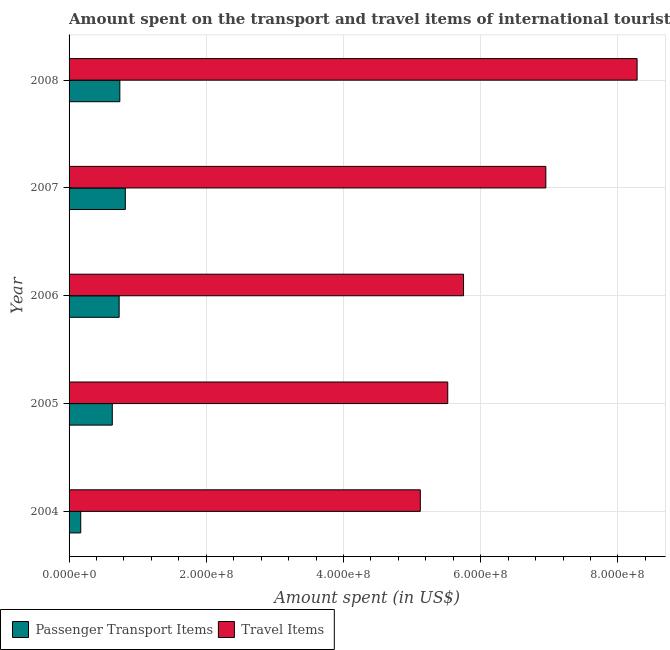How many different coloured bars are there?
Provide a succinct answer. 2. How many groups of bars are there?
Offer a very short reply. 5. Are the number of bars per tick equal to the number of legend labels?
Provide a short and direct response. Yes. How many bars are there on the 2nd tick from the top?
Provide a succinct answer. 2. What is the label of the 1st group of bars from the top?
Offer a terse response. 2008. In how many cases, is the number of bars for a given year not equal to the number of legend labels?
Offer a very short reply. 0. What is the amount spent on passenger transport items in 2008?
Your answer should be very brief. 7.40e+07. Across all years, what is the maximum amount spent on passenger transport items?
Keep it short and to the point. 8.20e+07. Across all years, what is the minimum amount spent in travel items?
Your answer should be very brief. 5.12e+08. What is the total amount spent in travel items in the graph?
Offer a terse response. 3.16e+09. What is the difference between the amount spent on passenger transport items in 2005 and that in 2006?
Your answer should be compact. -1.00e+07. What is the difference between the amount spent on passenger transport items in 2004 and the amount spent in travel items in 2005?
Offer a very short reply. -5.35e+08. What is the average amount spent in travel items per year?
Your response must be concise. 6.32e+08. In the year 2005, what is the difference between the amount spent in travel items and amount spent on passenger transport items?
Make the answer very short. 4.89e+08. What is the ratio of the amount spent in travel items in 2004 to that in 2005?
Provide a short and direct response. 0.93. Is the amount spent on passenger transport items in 2004 less than that in 2005?
Offer a very short reply. Yes. Is the difference between the amount spent on passenger transport items in 2004 and 2005 greater than the difference between the amount spent in travel items in 2004 and 2005?
Make the answer very short. No. What is the difference between the highest and the lowest amount spent in travel items?
Make the answer very short. 3.16e+08. What does the 1st bar from the top in 2006 represents?
Keep it short and to the point. Travel Items. What does the 2nd bar from the bottom in 2005 represents?
Your answer should be very brief. Travel Items. Are all the bars in the graph horizontal?
Your answer should be very brief. Yes. How many legend labels are there?
Your answer should be very brief. 2. What is the title of the graph?
Make the answer very short. Amount spent on the transport and travel items of international tourists visited in Macao. Does "Exports of goods" appear as one of the legend labels in the graph?
Ensure brevity in your answer.  No. What is the label or title of the X-axis?
Ensure brevity in your answer.  Amount spent (in US$). What is the label or title of the Y-axis?
Your answer should be compact. Year. What is the Amount spent (in US$) in Passenger Transport Items in 2004?
Keep it short and to the point. 1.70e+07. What is the Amount spent (in US$) in Travel Items in 2004?
Your response must be concise. 5.12e+08. What is the Amount spent (in US$) of Passenger Transport Items in 2005?
Provide a short and direct response. 6.30e+07. What is the Amount spent (in US$) of Travel Items in 2005?
Your answer should be compact. 5.52e+08. What is the Amount spent (in US$) of Passenger Transport Items in 2006?
Give a very brief answer. 7.30e+07. What is the Amount spent (in US$) in Travel Items in 2006?
Offer a very short reply. 5.75e+08. What is the Amount spent (in US$) in Passenger Transport Items in 2007?
Provide a succinct answer. 8.20e+07. What is the Amount spent (in US$) of Travel Items in 2007?
Make the answer very short. 6.95e+08. What is the Amount spent (in US$) in Passenger Transport Items in 2008?
Your answer should be very brief. 7.40e+07. What is the Amount spent (in US$) in Travel Items in 2008?
Ensure brevity in your answer.  8.28e+08. Across all years, what is the maximum Amount spent (in US$) in Passenger Transport Items?
Ensure brevity in your answer.  8.20e+07. Across all years, what is the maximum Amount spent (in US$) in Travel Items?
Ensure brevity in your answer.  8.28e+08. Across all years, what is the minimum Amount spent (in US$) of Passenger Transport Items?
Provide a short and direct response. 1.70e+07. Across all years, what is the minimum Amount spent (in US$) in Travel Items?
Give a very brief answer. 5.12e+08. What is the total Amount spent (in US$) of Passenger Transport Items in the graph?
Offer a terse response. 3.09e+08. What is the total Amount spent (in US$) of Travel Items in the graph?
Provide a short and direct response. 3.16e+09. What is the difference between the Amount spent (in US$) in Passenger Transport Items in 2004 and that in 2005?
Offer a terse response. -4.60e+07. What is the difference between the Amount spent (in US$) in Travel Items in 2004 and that in 2005?
Keep it short and to the point. -4.00e+07. What is the difference between the Amount spent (in US$) in Passenger Transport Items in 2004 and that in 2006?
Keep it short and to the point. -5.60e+07. What is the difference between the Amount spent (in US$) in Travel Items in 2004 and that in 2006?
Your response must be concise. -6.30e+07. What is the difference between the Amount spent (in US$) in Passenger Transport Items in 2004 and that in 2007?
Give a very brief answer. -6.50e+07. What is the difference between the Amount spent (in US$) in Travel Items in 2004 and that in 2007?
Offer a terse response. -1.83e+08. What is the difference between the Amount spent (in US$) in Passenger Transport Items in 2004 and that in 2008?
Keep it short and to the point. -5.70e+07. What is the difference between the Amount spent (in US$) in Travel Items in 2004 and that in 2008?
Your answer should be compact. -3.16e+08. What is the difference between the Amount spent (in US$) in Passenger Transport Items in 2005 and that in 2006?
Your response must be concise. -1.00e+07. What is the difference between the Amount spent (in US$) of Travel Items in 2005 and that in 2006?
Your answer should be compact. -2.30e+07. What is the difference between the Amount spent (in US$) in Passenger Transport Items in 2005 and that in 2007?
Offer a terse response. -1.90e+07. What is the difference between the Amount spent (in US$) of Travel Items in 2005 and that in 2007?
Offer a very short reply. -1.43e+08. What is the difference between the Amount spent (in US$) of Passenger Transport Items in 2005 and that in 2008?
Provide a short and direct response. -1.10e+07. What is the difference between the Amount spent (in US$) in Travel Items in 2005 and that in 2008?
Offer a terse response. -2.76e+08. What is the difference between the Amount spent (in US$) of Passenger Transport Items in 2006 and that in 2007?
Make the answer very short. -9.00e+06. What is the difference between the Amount spent (in US$) in Travel Items in 2006 and that in 2007?
Your response must be concise. -1.20e+08. What is the difference between the Amount spent (in US$) in Travel Items in 2006 and that in 2008?
Provide a succinct answer. -2.53e+08. What is the difference between the Amount spent (in US$) of Travel Items in 2007 and that in 2008?
Offer a very short reply. -1.33e+08. What is the difference between the Amount spent (in US$) in Passenger Transport Items in 2004 and the Amount spent (in US$) in Travel Items in 2005?
Offer a very short reply. -5.35e+08. What is the difference between the Amount spent (in US$) in Passenger Transport Items in 2004 and the Amount spent (in US$) in Travel Items in 2006?
Give a very brief answer. -5.58e+08. What is the difference between the Amount spent (in US$) of Passenger Transport Items in 2004 and the Amount spent (in US$) of Travel Items in 2007?
Keep it short and to the point. -6.78e+08. What is the difference between the Amount spent (in US$) in Passenger Transport Items in 2004 and the Amount spent (in US$) in Travel Items in 2008?
Ensure brevity in your answer.  -8.11e+08. What is the difference between the Amount spent (in US$) in Passenger Transport Items in 2005 and the Amount spent (in US$) in Travel Items in 2006?
Your answer should be very brief. -5.12e+08. What is the difference between the Amount spent (in US$) of Passenger Transport Items in 2005 and the Amount spent (in US$) of Travel Items in 2007?
Your response must be concise. -6.32e+08. What is the difference between the Amount spent (in US$) in Passenger Transport Items in 2005 and the Amount spent (in US$) in Travel Items in 2008?
Make the answer very short. -7.65e+08. What is the difference between the Amount spent (in US$) in Passenger Transport Items in 2006 and the Amount spent (in US$) in Travel Items in 2007?
Your response must be concise. -6.22e+08. What is the difference between the Amount spent (in US$) in Passenger Transport Items in 2006 and the Amount spent (in US$) in Travel Items in 2008?
Provide a short and direct response. -7.55e+08. What is the difference between the Amount spent (in US$) of Passenger Transport Items in 2007 and the Amount spent (in US$) of Travel Items in 2008?
Provide a succinct answer. -7.46e+08. What is the average Amount spent (in US$) of Passenger Transport Items per year?
Provide a succinct answer. 6.18e+07. What is the average Amount spent (in US$) of Travel Items per year?
Your response must be concise. 6.32e+08. In the year 2004, what is the difference between the Amount spent (in US$) of Passenger Transport Items and Amount spent (in US$) of Travel Items?
Provide a short and direct response. -4.95e+08. In the year 2005, what is the difference between the Amount spent (in US$) in Passenger Transport Items and Amount spent (in US$) in Travel Items?
Your response must be concise. -4.89e+08. In the year 2006, what is the difference between the Amount spent (in US$) of Passenger Transport Items and Amount spent (in US$) of Travel Items?
Your answer should be compact. -5.02e+08. In the year 2007, what is the difference between the Amount spent (in US$) in Passenger Transport Items and Amount spent (in US$) in Travel Items?
Keep it short and to the point. -6.13e+08. In the year 2008, what is the difference between the Amount spent (in US$) of Passenger Transport Items and Amount spent (in US$) of Travel Items?
Provide a succinct answer. -7.54e+08. What is the ratio of the Amount spent (in US$) of Passenger Transport Items in 2004 to that in 2005?
Your answer should be compact. 0.27. What is the ratio of the Amount spent (in US$) of Travel Items in 2004 to that in 2005?
Offer a very short reply. 0.93. What is the ratio of the Amount spent (in US$) of Passenger Transport Items in 2004 to that in 2006?
Offer a very short reply. 0.23. What is the ratio of the Amount spent (in US$) of Travel Items in 2004 to that in 2006?
Your answer should be compact. 0.89. What is the ratio of the Amount spent (in US$) in Passenger Transport Items in 2004 to that in 2007?
Your answer should be compact. 0.21. What is the ratio of the Amount spent (in US$) in Travel Items in 2004 to that in 2007?
Provide a succinct answer. 0.74. What is the ratio of the Amount spent (in US$) in Passenger Transport Items in 2004 to that in 2008?
Keep it short and to the point. 0.23. What is the ratio of the Amount spent (in US$) of Travel Items in 2004 to that in 2008?
Your response must be concise. 0.62. What is the ratio of the Amount spent (in US$) in Passenger Transport Items in 2005 to that in 2006?
Give a very brief answer. 0.86. What is the ratio of the Amount spent (in US$) of Passenger Transport Items in 2005 to that in 2007?
Ensure brevity in your answer.  0.77. What is the ratio of the Amount spent (in US$) in Travel Items in 2005 to that in 2007?
Ensure brevity in your answer.  0.79. What is the ratio of the Amount spent (in US$) in Passenger Transport Items in 2005 to that in 2008?
Ensure brevity in your answer.  0.85. What is the ratio of the Amount spent (in US$) of Travel Items in 2005 to that in 2008?
Ensure brevity in your answer.  0.67. What is the ratio of the Amount spent (in US$) of Passenger Transport Items in 2006 to that in 2007?
Offer a very short reply. 0.89. What is the ratio of the Amount spent (in US$) in Travel Items in 2006 to that in 2007?
Give a very brief answer. 0.83. What is the ratio of the Amount spent (in US$) in Passenger Transport Items in 2006 to that in 2008?
Provide a short and direct response. 0.99. What is the ratio of the Amount spent (in US$) of Travel Items in 2006 to that in 2008?
Provide a short and direct response. 0.69. What is the ratio of the Amount spent (in US$) of Passenger Transport Items in 2007 to that in 2008?
Provide a succinct answer. 1.11. What is the ratio of the Amount spent (in US$) of Travel Items in 2007 to that in 2008?
Ensure brevity in your answer.  0.84. What is the difference between the highest and the second highest Amount spent (in US$) in Passenger Transport Items?
Provide a short and direct response. 8.00e+06. What is the difference between the highest and the second highest Amount spent (in US$) of Travel Items?
Your response must be concise. 1.33e+08. What is the difference between the highest and the lowest Amount spent (in US$) in Passenger Transport Items?
Your response must be concise. 6.50e+07. What is the difference between the highest and the lowest Amount spent (in US$) of Travel Items?
Provide a short and direct response. 3.16e+08. 